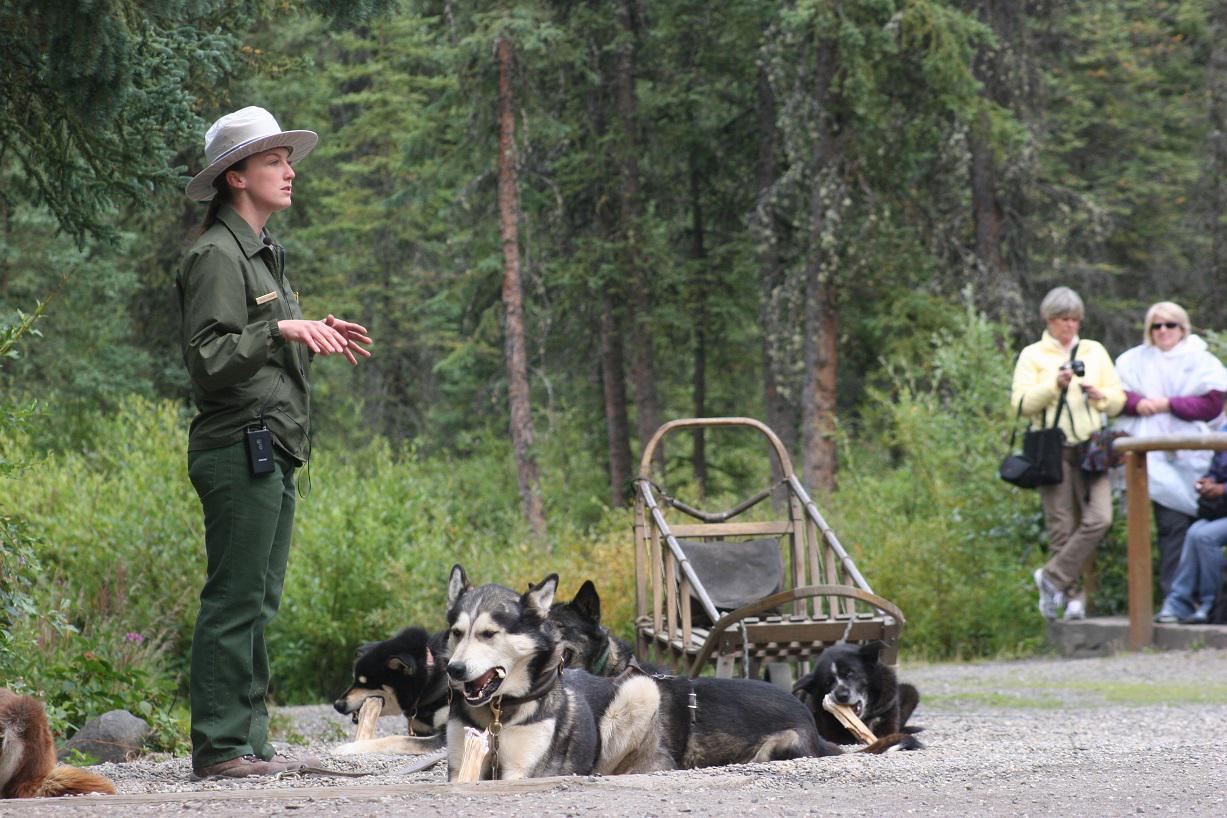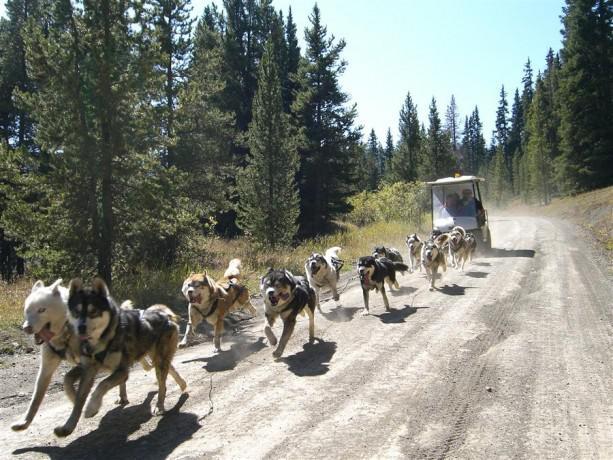The first image is the image on the left, the second image is the image on the right. Evaluate the accuracy of this statement regarding the images: "Right image shows a team of sled dogs headed straight toward the camera, and left image includes treeless mountains.". Is it true? Answer yes or no. No. The first image is the image on the left, the second image is the image on the right. Assess this claim about the two images: "Three people are riding a sled in one of the images.". Correct or not? Answer yes or no. No. 